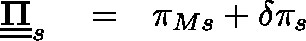<formula> <loc_0><loc_0><loc_500><loc_500>\begin{array} { r l r } { \underline { { \underline { \Pi } } } _ { s } } & = } & { \pi _ { M s } + \delta \pi _ { s } } \end{array}</formula> 